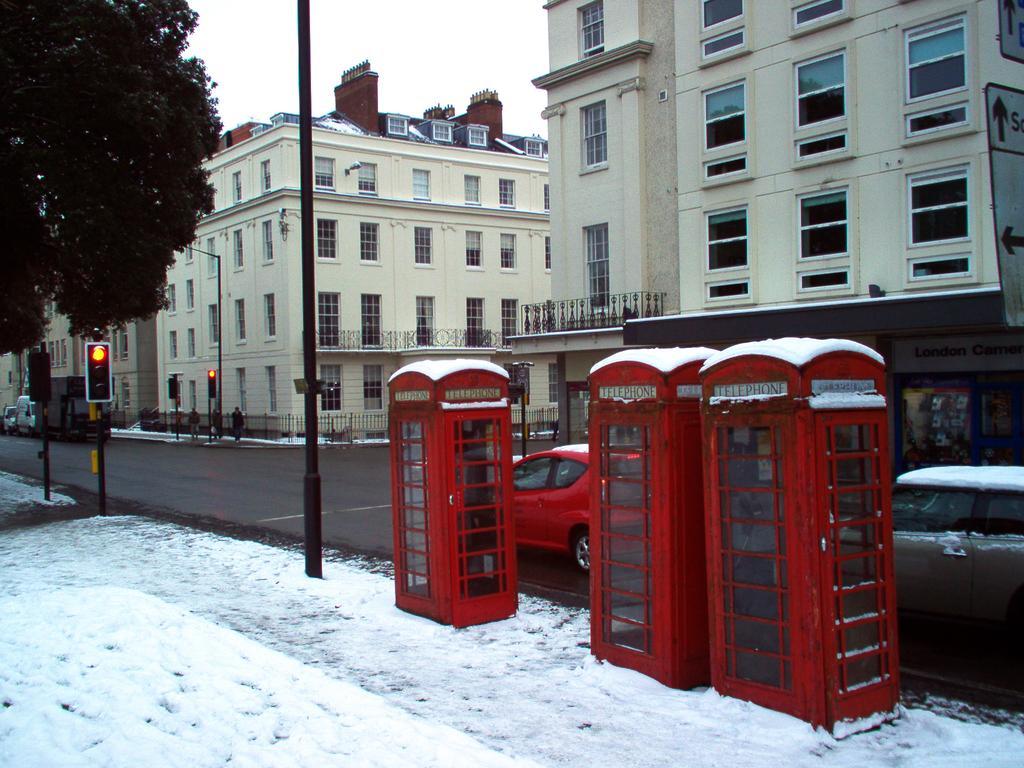In one or two sentences, can you explain what this image depicts? In this image there is road. There is full snow in the foreground. There are buildings and vehicles. There is tree on the left side. There are signal poles. There is sky. 